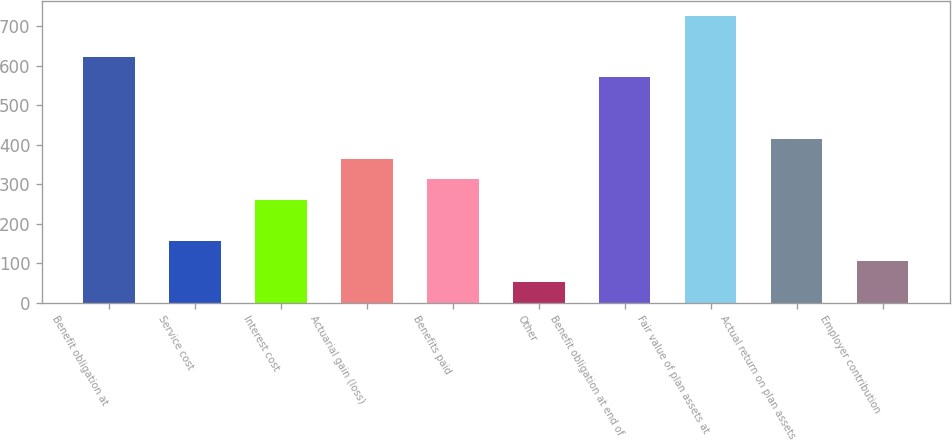Convert chart. <chart><loc_0><loc_0><loc_500><loc_500><bar_chart><fcel>Benefit obligation at<fcel>Service cost<fcel>Interest cost<fcel>Actuarial gain (loss)<fcel>Benefits paid<fcel>Other<fcel>Benefit obligation at end of<fcel>Fair value of plan assets at<fcel>Actual return on plan assets<fcel>Employer contribution<nl><fcel>623.52<fcel>156.33<fcel>260.15<fcel>363.97<fcel>312.06<fcel>52.51<fcel>571.61<fcel>727.34<fcel>415.88<fcel>104.42<nl></chart> 